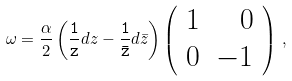Convert formula to latex. <formula><loc_0><loc_0><loc_500><loc_500>\omega = \frac { \alpha } { 2 } \left ( { \tt \frac { 1 } { z } } d z - { \tt \frac { 1 } { \bar { z } } } d \bar { z } \right ) \left ( \begin{array} { r r } 1 & 0 \\ 0 & - 1 \end{array} \right ) \, ,</formula> 